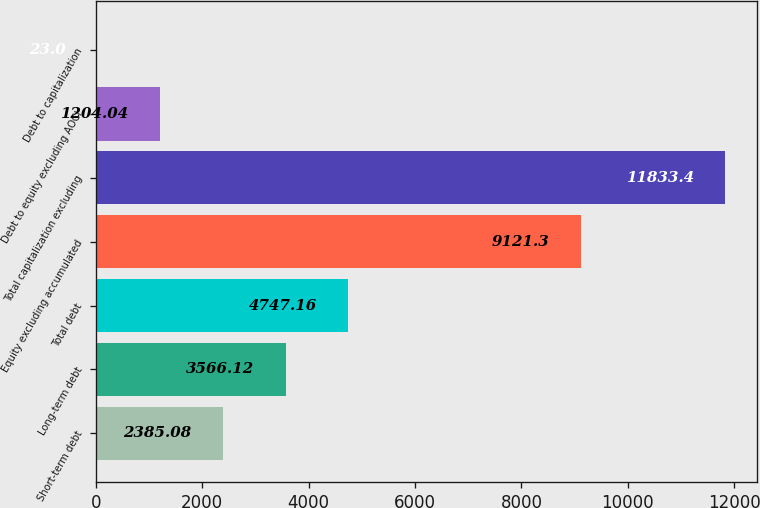<chart> <loc_0><loc_0><loc_500><loc_500><bar_chart><fcel>Short-term debt<fcel>Long-term debt<fcel>Total debt<fcel>Equity excluding accumulated<fcel>Total capitalization excluding<fcel>Debt to equity excluding AOCI<fcel>Debt to capitalization<nl><fcel>2385.08<fcel>3566.12<fcel>4747.16<fcel>9121.3<fcel>11833.4<fcel>1204.04<fcel>23<nl></chart> 